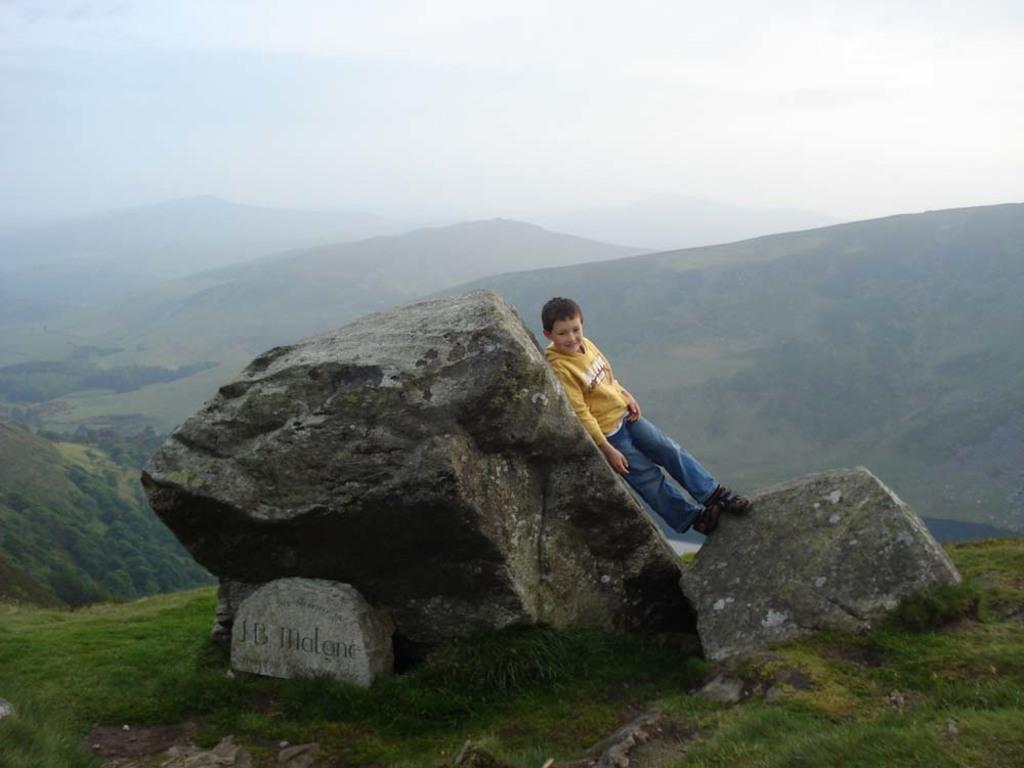What is the main subject of the image? The main subject of the image is a kid. Where is the kid located in the image? The kid is standing on a rock. What can be seen in the background of the image? There are mountains in the background of the image. What type of orange is the kid holding in the image? There is no orange present in the image; the kid is standing on a rock with mountains in the background. 